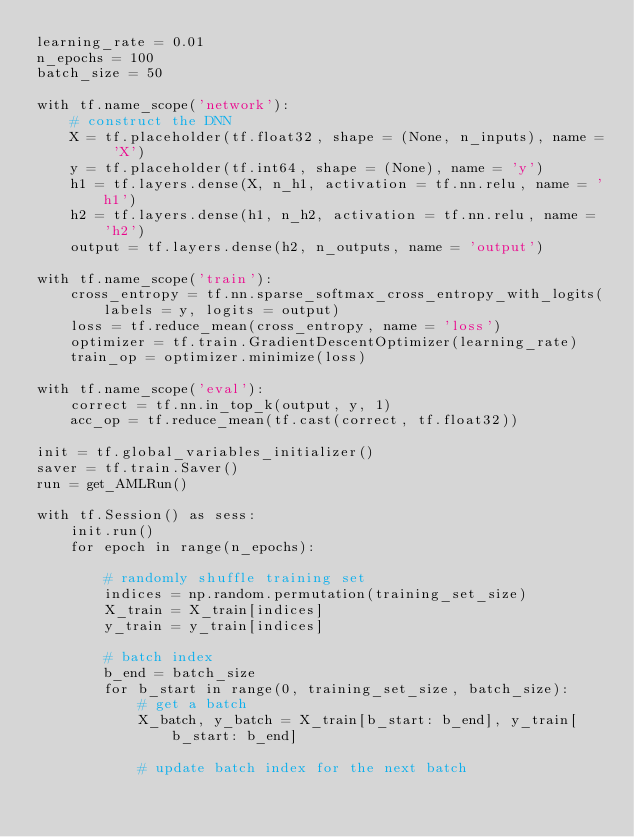<code> <loc_0><loc_0><loc_500><loc_500><_Python_>learning_rate = 0.01
n_epochs = 100
batch_size = 50

with tf.name_scope('network'):
    # construct the DNN
    X = tf.placeholder(tf.float32, shape = (None, n_inputs), name = 'X')
    y = tf.placeholder(tf.int64, shape = (None), name = 'y')
    h1 = tf.layers.dense(X, n_h1, activation = tf.nn.relu, name = 'h1')
    h2 = tf.layers.dense(h1, n_h2, activation = tf.nn.relu, name = 'h2')
    output = tf.layers.dense(h2, n_outputs, name = 'output')

with tf.name_scope('train'):
    cross_entropy = tf.nn.sparse_softmax_cross_entropy_with_logits(labels = y, logits = output)
    loss = tf.reduce_mean(cross_entropy, name = 'loss')
    optimizer = tf.train.GradientDescentOptimizer(learning_rate)
    train_op = optimizer.minimize(loss)

with tf.name_scope('eval'):
    correct = tf.nn.in_top_k(output, y, 1)
    acc_op = tf.reduce_mean(tf.cast(correct, tf.float32))

init = tf.global_variables_initializer()
saver = tf.train.Saver()
run = get_AMLRun()

with tf.Session() as sess:
    init.run()
    for epoch in range(n_epochs):

        # randomly shuffle training set
        indices = np.random.permutation(training_set_size)
        X_train = X_train[indices]
        y_train = y_train[indices]

        # batch index
        b_end = batch_size
        for b_start in range(0, training_set_size, batch_size):
            # get a batch
            X_batch, y_batch = X_train[b_start: b_end], y_train[b_start: b_end]

            # update batch index for the next batch</code> 